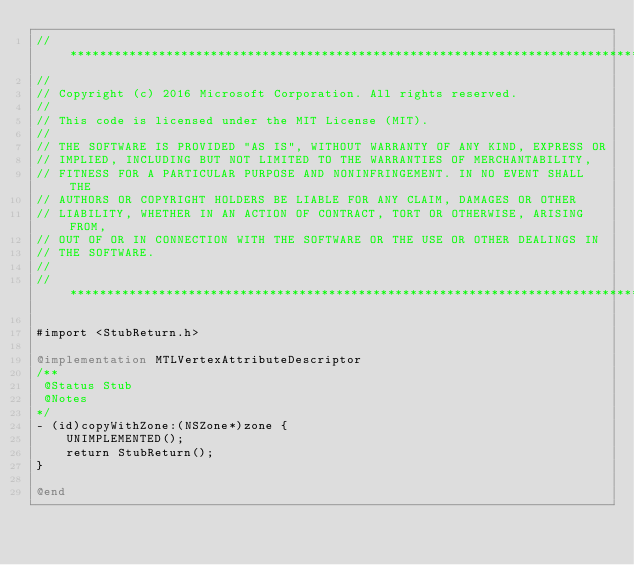Convert code to text. <code><loc_0><loc_0><loc_500><loc_500><_ObjectiveC_>//******************************************************************************
//
// Copyright (c) 2016 Microsoft Corporation. All rights reserved.
//
// This code is licensed under the MIT License (MIT).
//
// THE SOFTWARE IS PROVIDED "AS IS", WITHOUT WARRANTY OF ANY KIND, EXPRESS OR
// IMPLIED, INCLUDING BUT NOT LIMITED TO THE WARRANTIES OF MERCHANTABILITY,
// FITNESS FOR A PARTICULAR PURPOSE AND NONINFRINGEMENT. IN NO EVENT SHALL THE
// AUTHORS OR COPYRIGHT HOLDERS BE LIABLE FOR ANY CLAIM, DAMAGES OR OTHER
// LIABILITY, WHETHER IN AN ACTION OF CONTRACT, TORT OR OTHERWISE, ARISING FROM,
// OUT OF OR IN CONNECTION WITH THE SOFTWARE OR THE USE OR OTHER DEALINGS IN
// THE SOFTWARE.
//
//******************************************************************************

#import <StubReturn.h>

@implementation MTLVertexAttributeDescriptor
/**
 @Status Stub
 @Notes
*/
- (id)copyWithZone:(NSZone*)zone {
    UNIMPLEMENTED();
    return StubReturn();
}

@end
</code> 